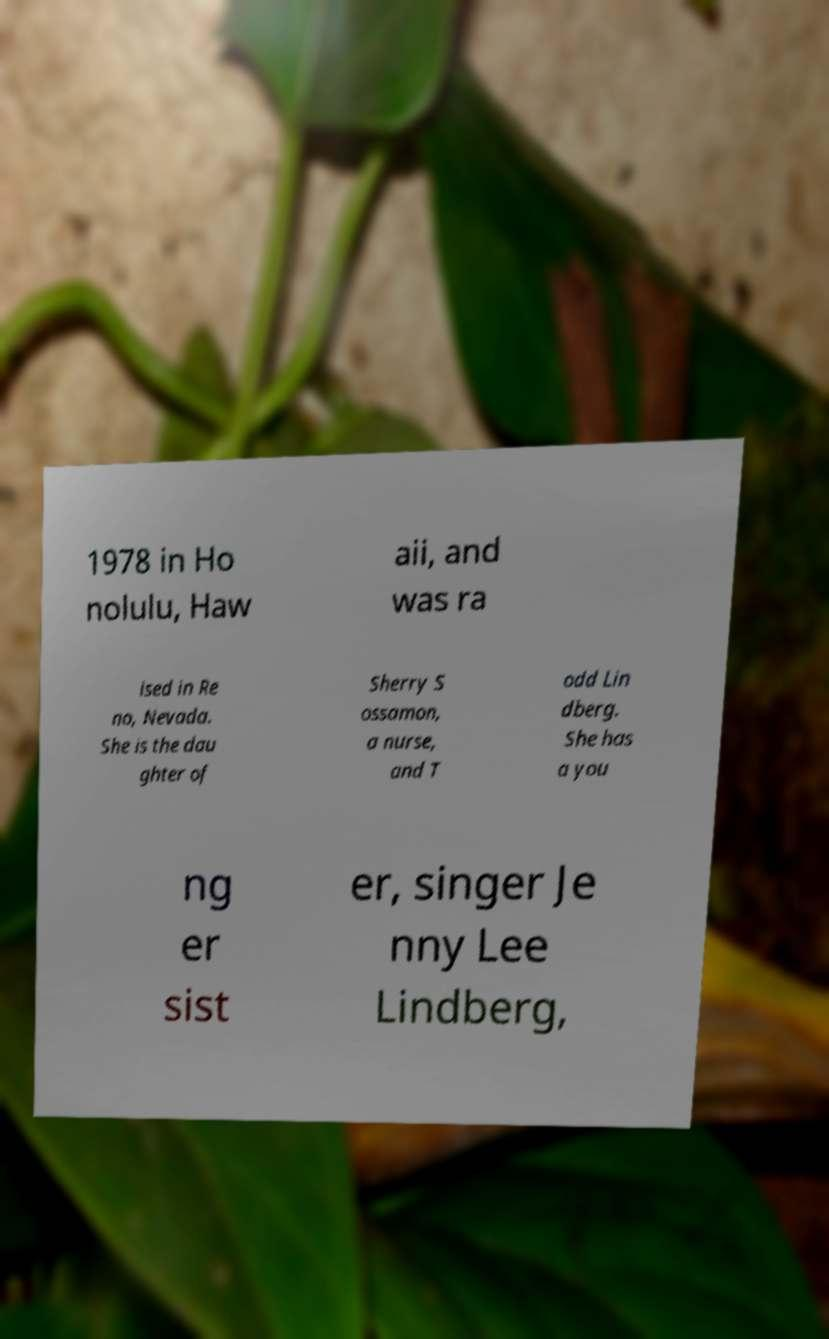What messages or text are displayed in this image? I need them in a readable, typed format. 1978 in Ho nolulu, Haw aii, and was ra ised in Re no, Nevada. She is the dau ghter of Sherry S ossamon, a nurse, and T odd Lin dberg. She has a you ng er sist er, singer Je nny Lee Lindberg, 